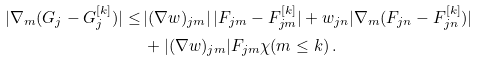Convert formula to latex. <formula><loc_0><loc_0><loc_500><loc_500>| \nabla _ { m } ( G _ { j } - G _ { j } ^ { [ k ] } ) | \leq \, & | ( \nabla w ) _ { j m } | \, | F _ { j m } - F ^ { [ k ] } _ { j m } | + w _ { j n } | \nabla _ { m } ( F _ { j n } - F ^ { [ k ] } _ { j n } ) | \\ & + | ( \nabla w ) _ { j m } | F _ { j m } \chi ( m \leq k ) \, .</formula> 